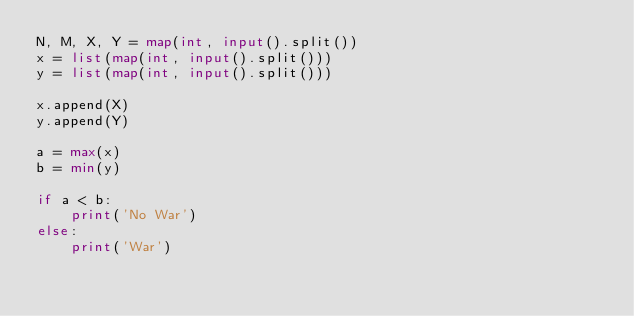Convert code to text. <code><loc_0><loc_0><loc_500><loc_500><_Python_>N, M, X, Y = map(int, input().split())
x = list(map(int, input().split()))
y = list(map(int, input().split()))

x.append(X)
y.append(Y)

a = max(x)
b = min(y)

if a < b:
    print('No War')
else:
    print('War')
</code> 